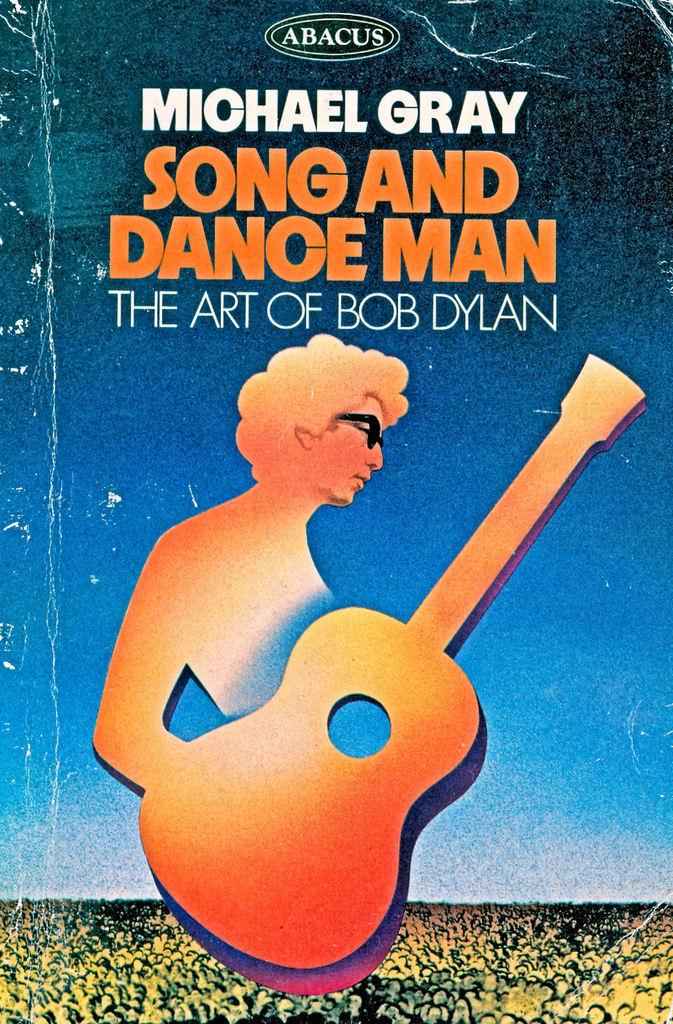<image>
Create a compact narrative representing the image presented. a lyrics book of the art of bob dylan 